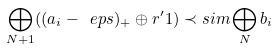<formula> <loc_0><loc_0><loc_500><loc_500>\bigoplus _ { N + 1 } ( ( a _ { i } - \ e p s ) _ { + } \oplus r ^ { \prime } 1 ) \prec s i m \bigoplus _ { N } b _ { i }</formula> 